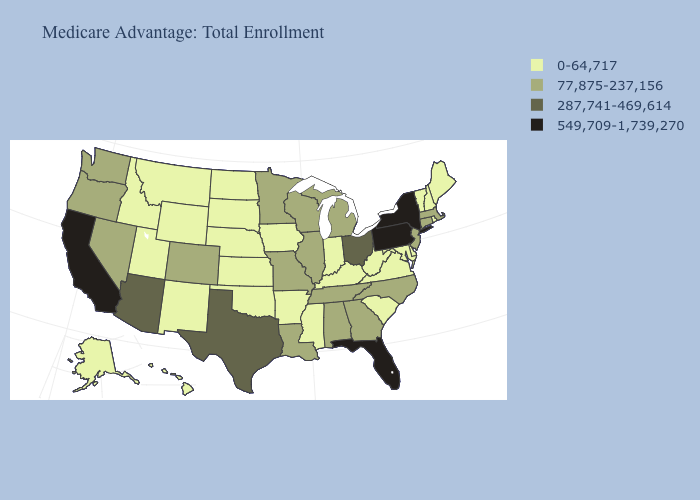What is the lowest value in states that border Nevada?
Keep it brief. 0-64,717. Which states have the lowest value in the Northeast?
Short answer required. Maine, New Hampshire, Rhode Island, Vermont. Name the states that have a value in the range 549,709-1,739,270?
Quick response, please. California, Florida, New York, Pennsylvania. Among the states that border Montana , which have the lowest value?
Be succinct. Idaho, North Dakota, South Dakota, Wyoming. What is the highest value in the USA?
Concise answer only. 549,709-1,739,270. Name the states that have a value in the range 0-64,717?
Answer briefly. Alaska, Arkansas, Delaware, Hawaii, Iowa, Idaho, Indiana, Kansas, Kentucky, Maryland, Maine, Mississippi, Montana, North Dakota, Nebraska, New Hampshire, New Mexico, Oklahoma, Rhode Island, South Carolina, South Dakota, Utah, Virginia, Vermont, West Virginia, Wyoming. Does the map have missing data?
Be succinct. No. Among the states that border New Hampshire , which have the highest value?
Short answer required. Massachusetts. Name the states that have a value in the range 549,709-1,739,270?
Quick response, please. California, Florida, New York, Pennsylvania. What is the value of West Virginia?
Concise answer only. 0-64,717. Name the states that have a value in the range 0-64,717?
Quick response, please. Alaska, Arkansas, Delaware, Hawaii, Iowa, Idaho, Indiana, Kansas, Kentucky, Maryland, Maine, Mississippi, Montana, North Dakota, Nebraska, New Hampshire, New Mexico, Oklahoma, Rhode Island, South Carolina, South Dakota, Utah, Virginia, Vermont, West Virginia, Wyoming. Which states have the lowest value in the USA?
Concise answer only. Alaska, Arkansas, Delaware, Hawaii, Iowa, Idaho, Indiana, Kansas, Kentucky, Maryland, Maine, Mississippi, Montana, North Dakota, Nebraska, New Hampshire, New Mexico, Oklahoma, Rhode Island, South Carolina, South Dakota, Utah, Virginia, Vermont, West Virginia, Wyoming. What is the value of Oklahoma?
Short answer required. 0-64,717. How many symbols are there in the legend?
Be succinct. 4. Name the states that have a value in the range 77,875-237,156?
Be succinct. Alabama, Colorado, Connecticut, Georgia, Illinois, Louisiana, Massachusetts, Michigan, Minnesota, Missouri, North Carolina, New Jersey, Nevada, Oregon, Tennessee, Washington, Wisconsin. 